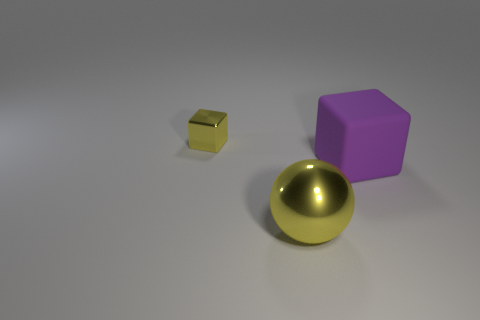Subtract all cubes. How many objects are left? 1 Add 1 blocks. How many objects exist? 4 Subtract all purple blocks. How many blocks are left? 1 Subtract 1 yellow spheres. How many objects are left? 2 Subtract 1 spheres. How many spheres are left? 0 Subtract all red blocks. Subtract all gray spheres. How many blocks are left? 2 Subtract all purple cylinders. How many gray spheres are left? 0 Subtract all large purple spheres. Subtract all small shiny things. How many objects are left? 2 Add 1 large yellow shiny things. How many large yellow shiny things are left? 2 Add 2 small yellow cylinders. How many small yellow cylinders exist? 2 